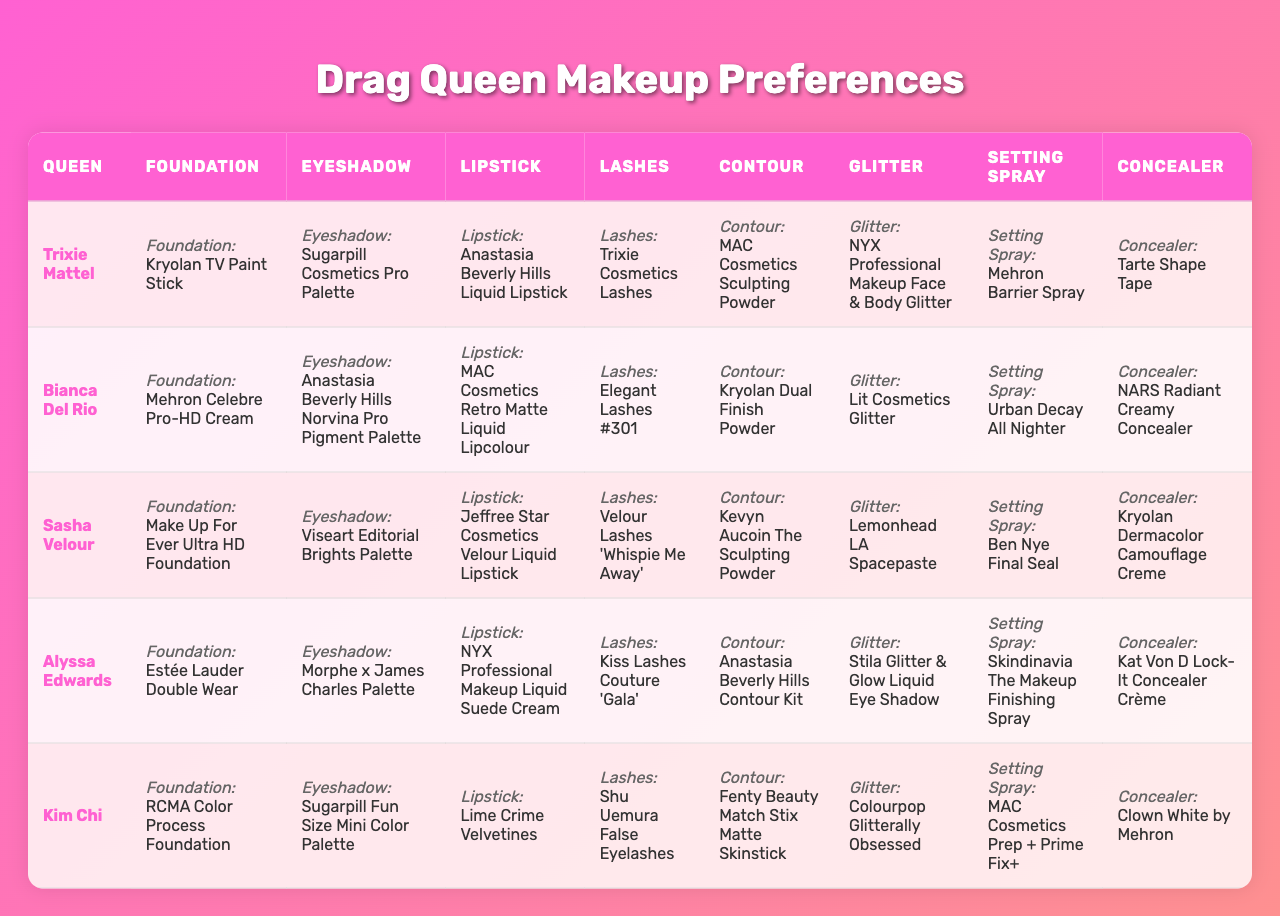What is the preferred foundation of Trixie Mattel? You can find Trixie Mattel's preferred foundation in her row under the "Foundation" column, which is listed as "Kryolan TV Paint Stick."
Answer: Kryolan TV Paint Stick Which drag queen uses MAC Cosmetics for contour? Look for the "Contour" column in the table and identify which queen has MAC Cosmetics listed as their preferred contour product. Trixie Mattel, Bianca Del Rio, and Alyssa Edwards share this preference.
Answer: Trixie Mattel, Bianca Del Rio, Alyssa Edwards Who prefers Tarte Shape Tape for concealer? Check the row for Trixie Mattel in the "Concealer" column, where Tarte Shape Tape is mentioned as her preferred choice.
Answer: Trixie Mattel What lipstick does Bianca Del Rio prefer? By referring to Bianca Del Rio's row in the "Lipstick" column, we see that she prefers "MAC Cosmetics Retro Matte Liquid Lipcolour."
Answer: MAC Cosmetics Retro Matte Liquid Lipcolour How many queens use Anastasia Beverly Hills products for foundation or contour? The "Foundation" and "Contour" columns are reviewed for any preferences for Anastasia Beverly Hills. Trixie Mattel and Alyssa Edwards use Anastasia Beverly Hills for contour; no queens mentioned it for foundation. Thus, only 2 queens use Anastasia for contour.
Answer: 2 Which product is most commonly preferred as a setting spray among the queens? The "Setting Spray" column is analyzed to see which product appears the most. Urban Decay All Nighter and Mehron Barrier Spray both have mentions among different queens, but can be narrowed down by frequency. There are two mentions of "MAC Cosmetics Prep + Prime Fix+."
Answer: MAC Cosmetics Prep + Prime Fix+ Which queen has the highest variety of brands in her makeup preferences? Review each queen's row for the variety of brands selected across all product categories. Counting diverse brands, Trixie Mattel features Kryolan, Sugarpill Cosmetics, Anastasia Beverly Hills, Trixie Cosmetics, MAC Cosmetics, NYX Professional Makeup, Mehron, and Tarte, showcasing 8 unique brands, which is the most among all queens.
Answer: Trixie Mattel Which product category has the least variation in brand usage? Inspecting the table reveals the product category for lashes shows "Trixie Cosmetics Lashes" and "Shu Uemura False Eyelashes" as the unique choices. Hence, it has lower brand variation as compared to other categories.
Answer: Lashes How many queens listed NYX Professional Makeup products in their preferences? By counting the mentions of NYX Professional Makeup across the table, it's found in the choices of Trixie Mattel for glitter and Alyssa Edwards for lipstick. Therefore, two queens favor NYX Professional Makeup.
Answer: 2 Are any of the queens using the same product for both contour and foundation? Inspecting the "Foundation" and "Contour," there are no queens who prefer identical products in these two categories. Thus, the answer is no.
Answer: No Which influential figure appears most often in the makeup preferences across the queens? The influence of brands is more important. After observing the brands used, it becomes evident that no single influencer product appears with high frequency across multiple queens with the data provided. Hence, no clear answer emerges in terms of shared product usage.
Answer: None 